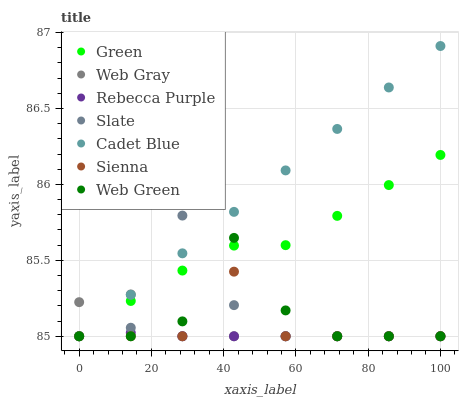Does Rebecca Purple have the minimum area under the curve?
Answer yes or no. Yes. Does Cadet Blue have the maximum area under the curve?
Answer yes or no. Yes. Does Slate have the minimum area under the curve?
Answer yes or no. No. Does Slate have the maximum area under the curve?
Answer yes or no. No. Is Cadet Blue the smoothest?
Answer yes or no. Yes. Is Slate the roughest?
Answer yes or no. Yes. Is Web Green the smoothest?
Answer yes or no. No. Is Web Green the roughest?
Answer yes or no. No. Does Cadet Blue have the lowest value?
Answer yes or no. Yes. Does Cadet Blue have the highest value?
Answer yes or no. Yes. Does Slate have the highest value?
Answer yes or no. No. Does Slate intersect Sienna?
Answer yes or no. Yes. Is Slate less than Sienna?
Answer yes or no. No. Is Slate greater than Sienna?
Answer yes or no. No. 